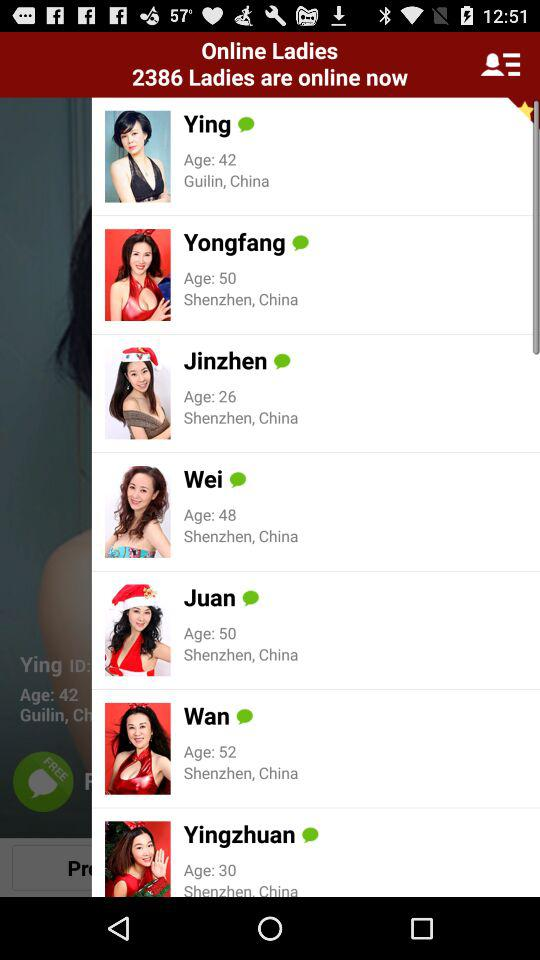What is the age of Wei? Wei is 48 years old. 